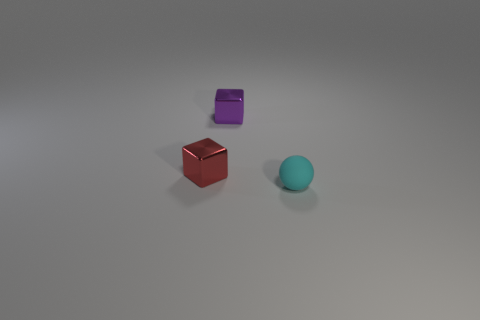Subtract all purple cubes. How many cubes are left? 1 Add 2 red balls. How many objects exist? 5 Subtract all blue spheres. How many red blocks are left? 1 Subtract 0 green cylinders. How many objects are left? 3 Subtract all blocks. How many objects are left? 1 Subtract 2 blocks. How many blocks are left? 0 Subtract all cyan blocks. Subtract all red spheres. How many blocks are left? 2 Subtract all matte spheres. Subtract all small red blocks. How many objects are left? 1 Add 3 purple things. How many purple things are left? 4 Add 1 spheres. How many spheres exist? 2 